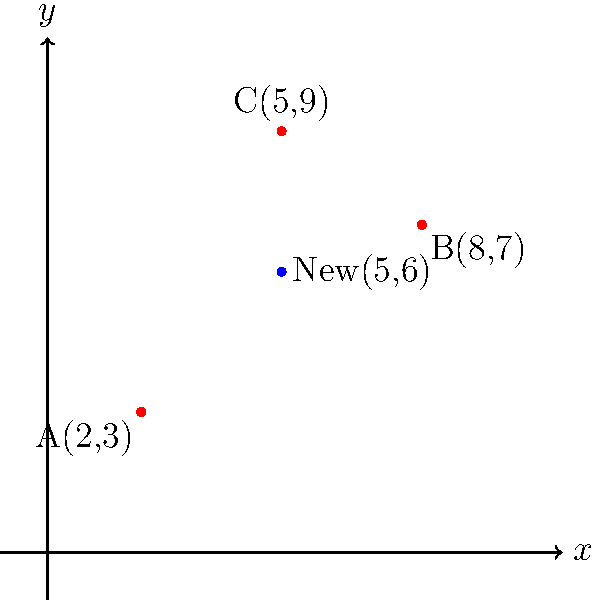As an NGO director, you're planning to establish a new initiative center that minimizes the total distance from three existing centers A(2,3), B(8,7), and C(5,9). Using the distance formula, calculate the total distance from the proposed new center at (5,6) to all three existing centers. Round your answer to two decimal places. To solve this problem, we'll use the distance formula between two points: 
$d = \sqrt{(x_2-x_1)^2 + (y_2-y_1)^2}$

Let's calculate the distance from the new center (5,6) to each existing center:

1. Distance to A(2,3):
   $d_A = \sqrt{(5-2)^2 + (6-3)^2} = \sqrt{3^2 + 3^2} = \sqrt{18} = 3\sqrt{2} \approx 4.24$

2. Distance to B(8,7):
   $d_B = \sqrt{(5-8)^2 + (6-7)^2} = \sqrt{(-3)^2 + (-1)^2} = \sqrt{10} \approx 3.16$

3. Distance to C(5,9):
   $d_C = \sqrt{(5-5)^2 + (6-9)^2} = \sqrt{0^2 + (-3)^2} = 3$

Now, we sum up all these distances:

Total distance = $d_A + d_B + d_C = 4.24 + 3.16 + 3 = 10.40$

Rounding to two decimal places, we get 10.40.
Answer: 10.40 units 